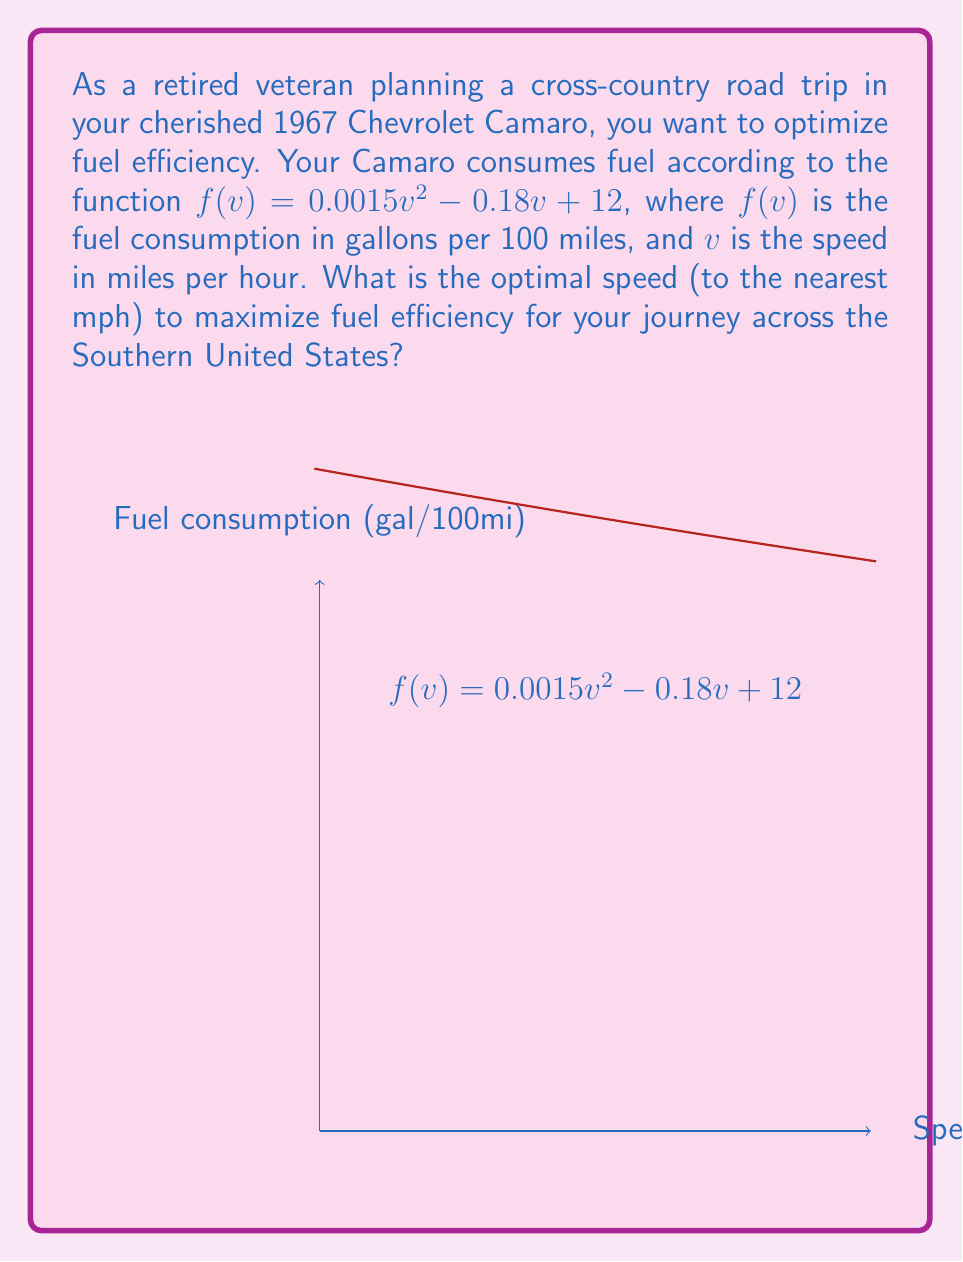Can you answer this question? To find the optimal speed for maximum fuel efficiency, we need to minimize the fuel consumption function $f(v)$. This can be done by finding the minimum point of the quadratic function.

Step 1: Find the derivative of $f(v)$
$$f'(v) = 0.003v - 0.18$$

Step 2: Set the derivative to zero and solve for v
$$0.003v - 0.18 = 0$$
$$0.003v = 0.18$$
$$v = \frac{0.18}{0.003} = 60$$

Step 3: Verify it's a minimum by checking the second derivative
$$f''(v) = 0.003 > 0$$
Since the second derivative is positive, this confirms that v = 60 is a minimum point.

Step 4: Round to the nearest mph
The optimal speed is 60 mph.
Answer: 60 mph 